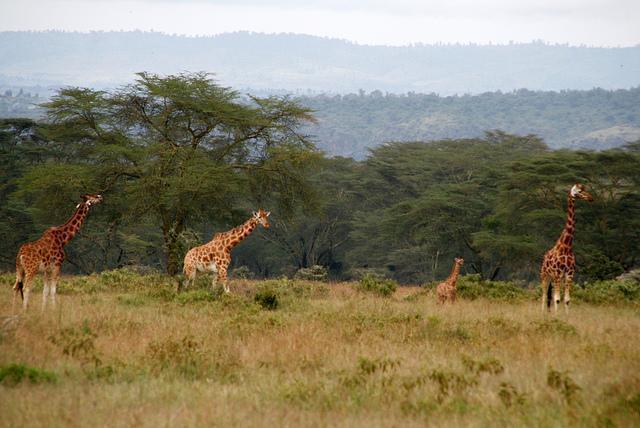What direction are the giraffes looking?
Select the accurate answer and provide justification: `Answer: choice
Rationale: srationale.`
Options: South, east, north, west. Answer: east.
Rationale: Their necks are both tilted to the right. 